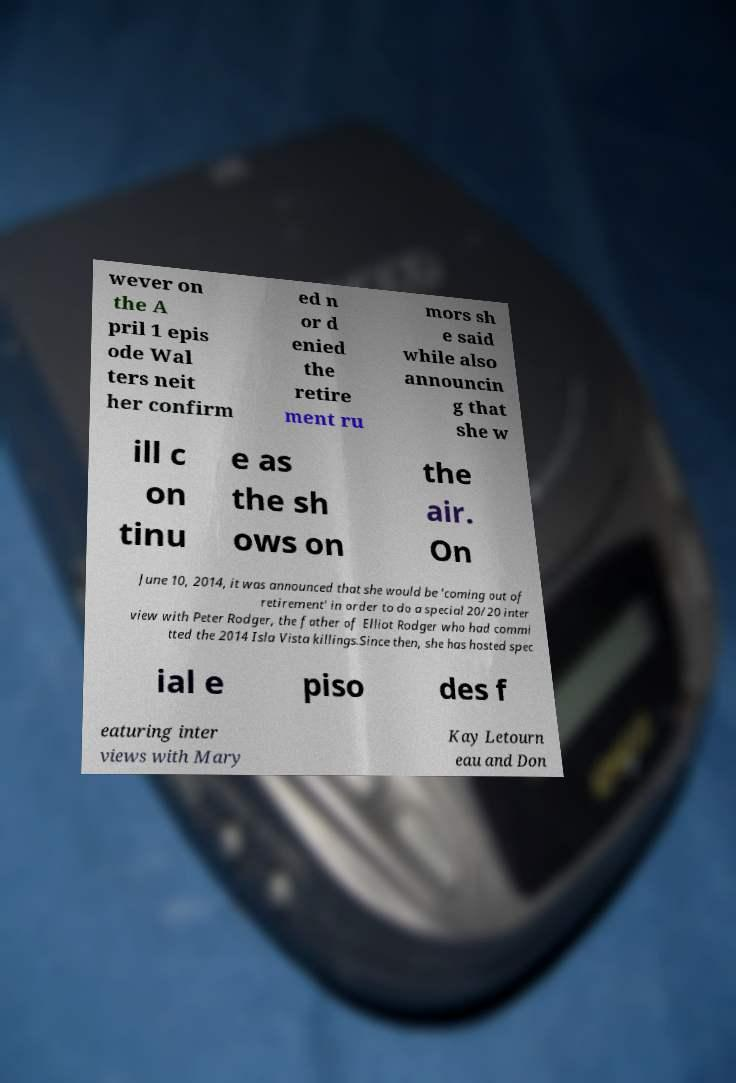Please identify and transcribe the text found in this image. wever on the A pril 1 epis ode Wal ters neit her confirm ed n or d enied the retire ment ru mors sh e said while also announcin g that she w ill c on tinu e as the sh ows on the air. On June 10, 2014, it was announced that she would be 'coming out of retirement' in order to do a special 20/20 inter view with Peter Rodger, the father of Elliot Rodger who had commi tted the 2014 Isla Vista killings.Since then, she has hosted spec ial e piso des f eaturing inter views with Mary Kay Letourn eau and Don 